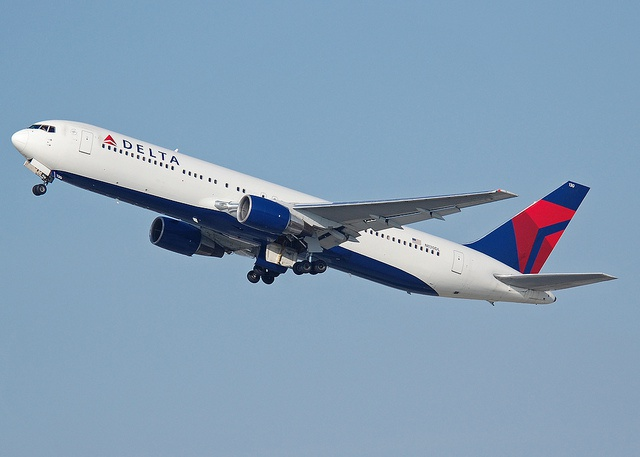Describe the objects in this image and their specific colors. I can see a airplane in darkgray, lightgray, navy, gray, and black tones in this image. 